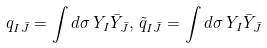Convert formula to latex. <formula><loc_0><loc_0><loc_500><loc_500>q _ { I \bar { J } } = \int d \sigma \, Y _ { I } \bar { Y } _ { \bar { J } } , \, \tilde { q } _ { I \bar { J } } = \int d \sigma \, Y _ { I } \bar { Y } _ { \bar { J } }</formula> 